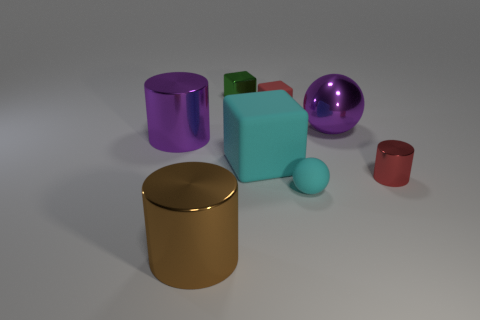Can you describe the largest object in the scene? Certainly! The largest object in the image is a purple cylinder with a reflective surface. It stands out due to its size and the shiny texture that catches the light. 